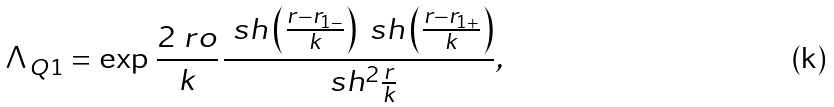Convert formula to latex. <formula><loc_0><loc_0><loc_500><loc_500>\Lambda _ { Q 1 } = \exp { \, \frac { 2 \ r o } { k } \, } \frac { \ s h \left ( \frac { r - r _ { 1 - } } { k } \right ) \ s h \left ( \frac { r - r _ { 1 + } } { k } \right ) } { \ s h ^ { 2 } \frac { r } { k } } ,</formula> 